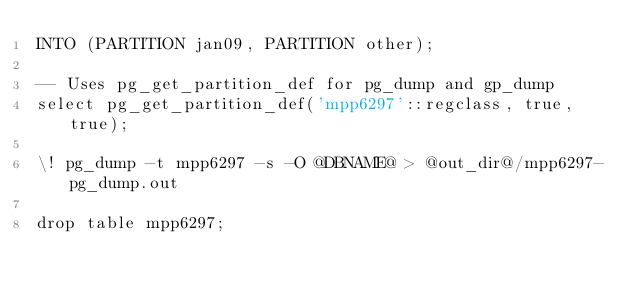Convert code to text. <code><loc_0><loc_0><loc_500><loc_500><_SQL_>INTO (PARTITION jan09, PARTITION other);

-- Uses pg_get_partition_def for pg_dump and gp_dump
select pg_get_partition_def('mpp6297'::regclass, true, true);

\! pg_dump -t mpp6297 -s -O @DBNAME@ > @out_dir@/mpp6297-pg_dump.out

drop table mpp6297;

</code> 